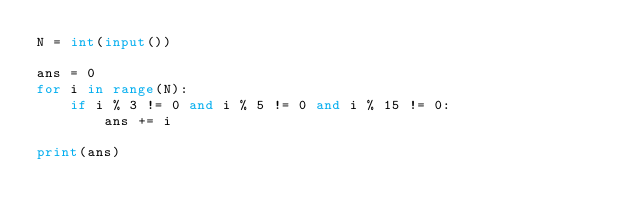<code> <loc_0><loc_0><loc_500><loc_500><_Python_>N = int(input())

ans = 0
for i in range(N):
	if i % 3 != 0 and i % 5 != 0 and i % 15 != 0:
		ans += i

print(ans)
</code> 